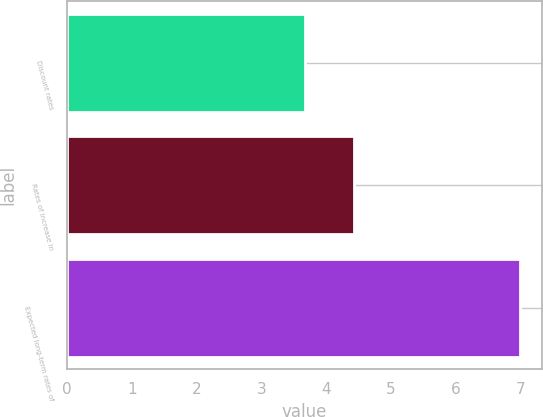Convert chart. <chart><loc_0><loc_0><loc_500><loc_500><bar_chart><fcel>Discount rates<fcel>Rates of increase in<fcel>Expected long-term rates of<nl><fcel>3.67<fcel>4.43<fcel>6.98<nl></chart> 